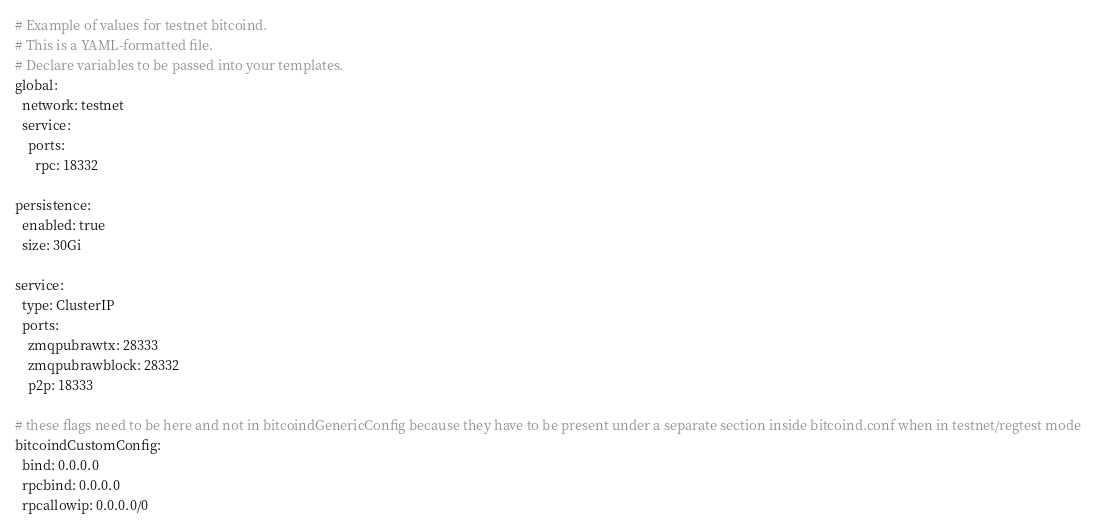<code> <loc_0><loc_0><loc_500><loc_500><_YAML_># Example of values for testnet bitcoind.
# This is a YAML-formatted file.
# Declare variables to be passed into your templates.
global:
  network: testnet
  service:
    ports:
      rpc: 18332

persistence:
  enabled: true
  size: 30Gi

service:
  type: ClusterIP
  ports:
    zmqpubrawtx: 28333
    zmqpubrawblock: 28332
    p2p: 18333

# these flags need to be here and not in bitcoindGenericConfig because they have to be present under a separate section inside bitcoind.conf when in testnet/regtest mode
bitcoindCustomConfig:
  bind: 0.0.0.0
  rpcbind: 0.0.0.0
  rpcallowip: 0.0.0.0/0
</code> 